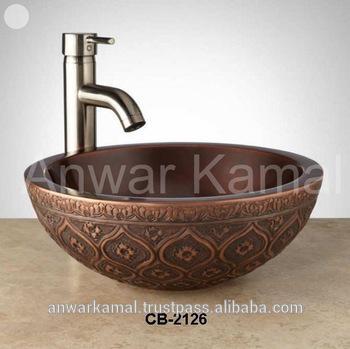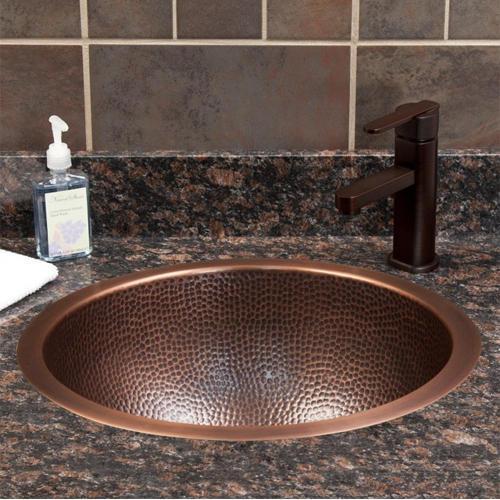The first image is the image on the left, the second image is the image on the right. For the images shown, is this caption "Water is running from a faucet in one of the images." true? Answer yes or no. No. The first image is the image on the left, the second image is the image on the right. Examine the images to the left and right. Is the description "Water is coming out of one of the faucets." accurate? Answer yes or no. No. 